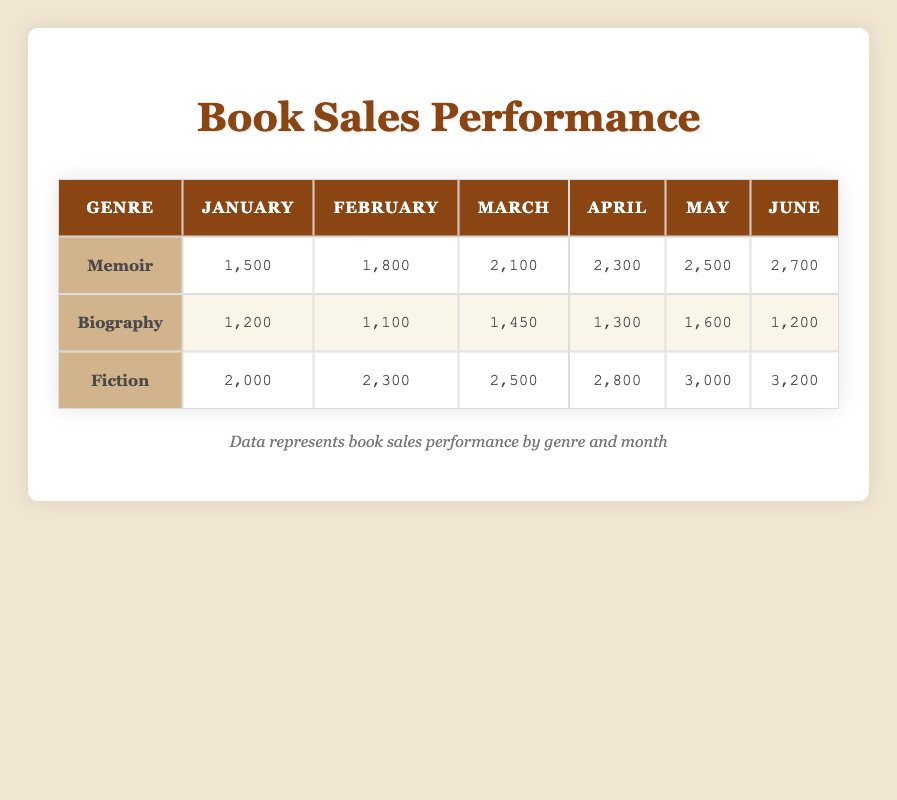What was the total sales of Memoir books in April? The sales for Memoir books in April is recorded as 2,300. Thus, total sales for Memoir books in that month is simply 2,300.
Answer: 2,300 In which month did Fiction book sales first exceed 3,000? The table shows that the sales for Fiction books is 3,000 in May and 3,200 in June. No month prior to May had 3,000 or more sales, making May the first month to exceed this threshold.
Answer: May What is the average sales for Biography books over the six months? To find the average sales for Biography, sum the sales for each month (1,200 + 1,100 + 1,450 + 1,300 + 1,600 + 1,200 = 7,850) and divide by the number of months (6). The average is 7,850 / 6 = 1,308.33.
Answer: 1,308.33 Did Memoir sales ever exceed Biography sales in June? In June, Memoir sales were 2,700 while Biography sales were 1,200.  Since 2,700 is greater than 1,200, it confirms that Memoir sales did exceed Biography sales in June.
Answer: Yes What is the total sales of all genres combined for February? For February, Memoir sales were 1,800, Biography sales were 1,100, and Fiction sales were 2,300. Adding these together gives a total of 1,800 + 1,100 + 2,300 = 5,200.
Answer: 5,200 Which genre had the highest month-to-month increase in sales during the month of March? In March, Memoir continued to increase from 2,100 in February to 2,300 in April, resulting in an increase of 200. Biography sales increased from 1,100 in February to 1,450 in March (a 350 increase), and Fiction sales sustained growth from 2,300 to 2,500 (a 200 increase). Thus, the largest increase was in Biography with an increase of 350.
Answer: Biography 